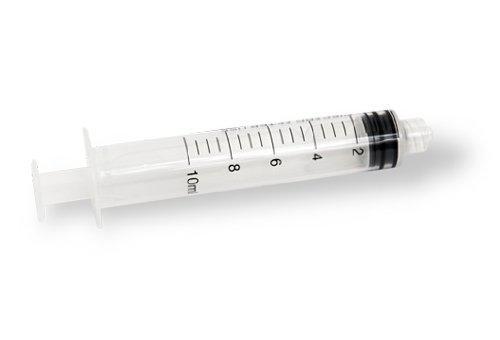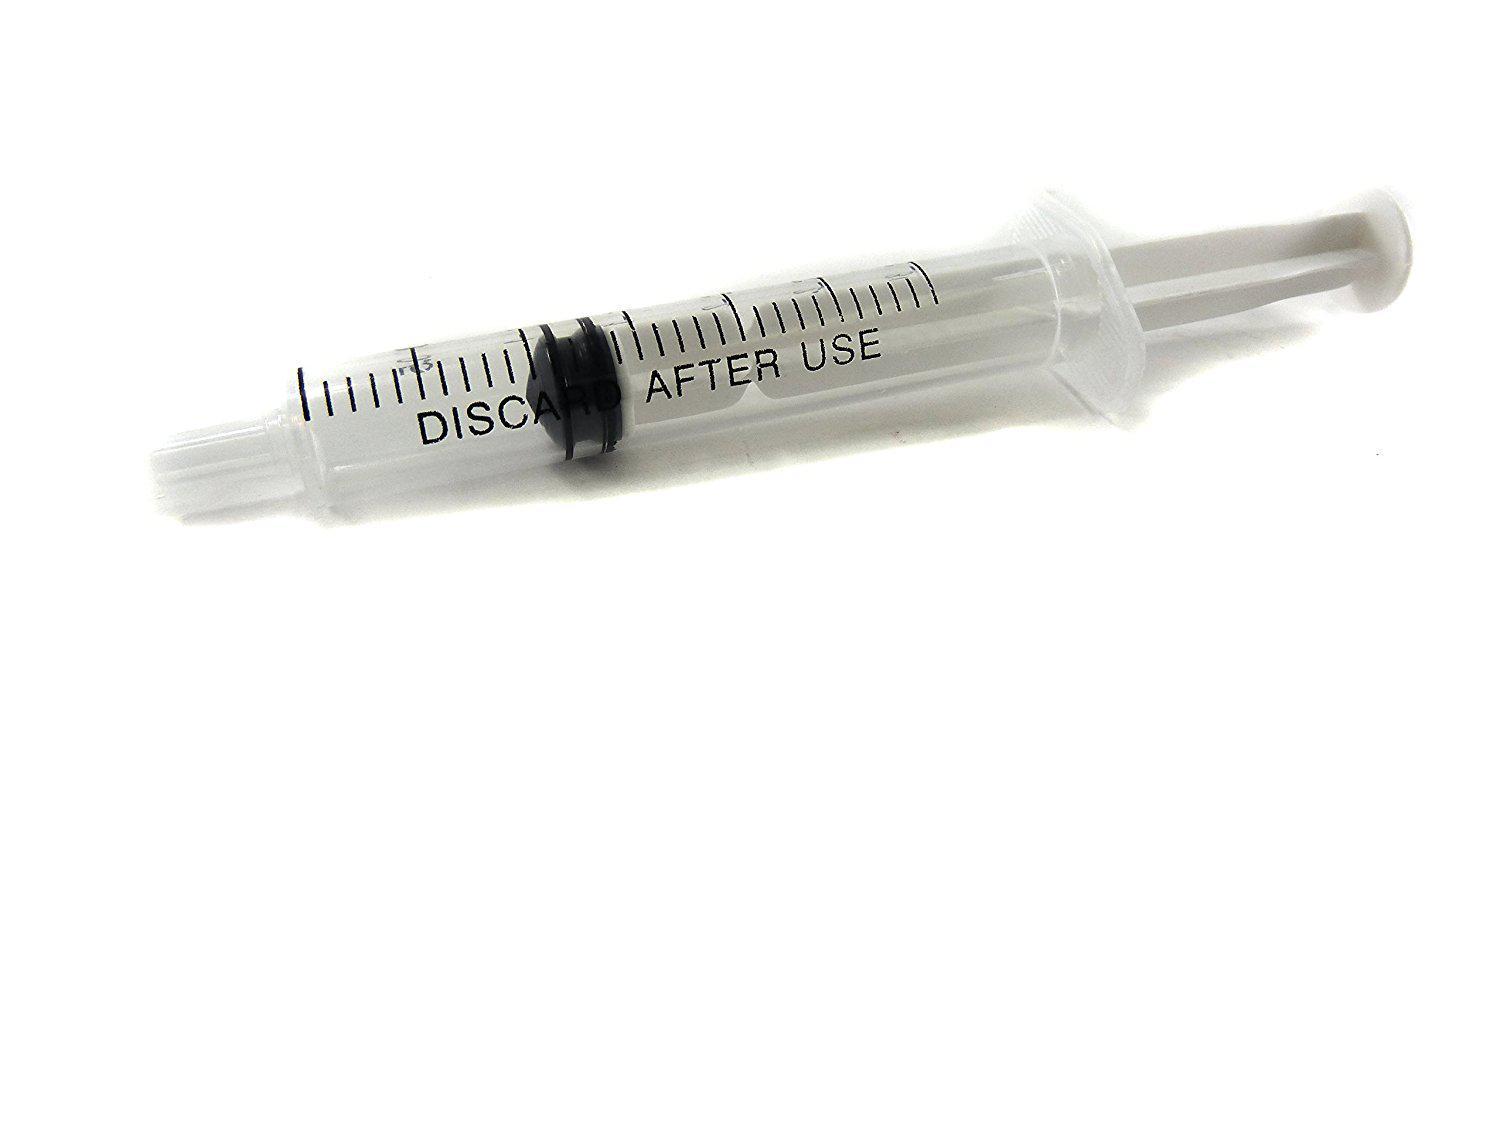The first image is the image on the left, the second image is the image on the right. Examine the images to the left and right. Is the description "Both images show syringes with needles attached." accurate? Answer yes or no. No. The first image is the image on the left, the second image is the image on the right. Assess this claim about the two images: "Both syringes do not have the needle attached.". Correct or not? Answer yes or no. Yes. 